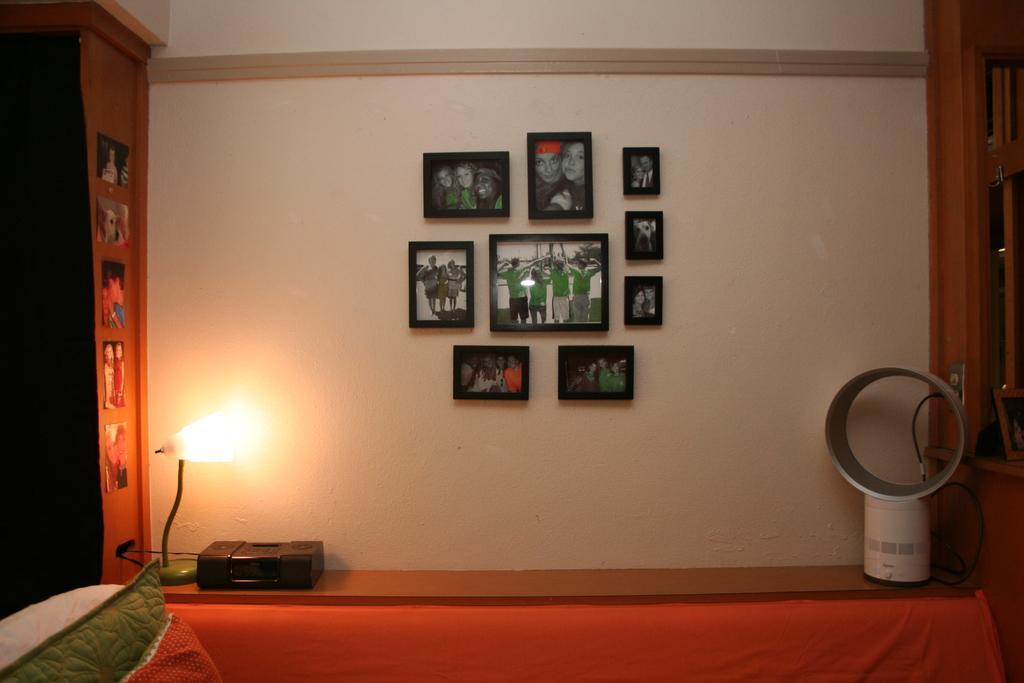Could you give a brief overview of what you see in this image? In this picture we can see pillows, device, lamp, photos, cable, photo frames on the wall and some objects. 